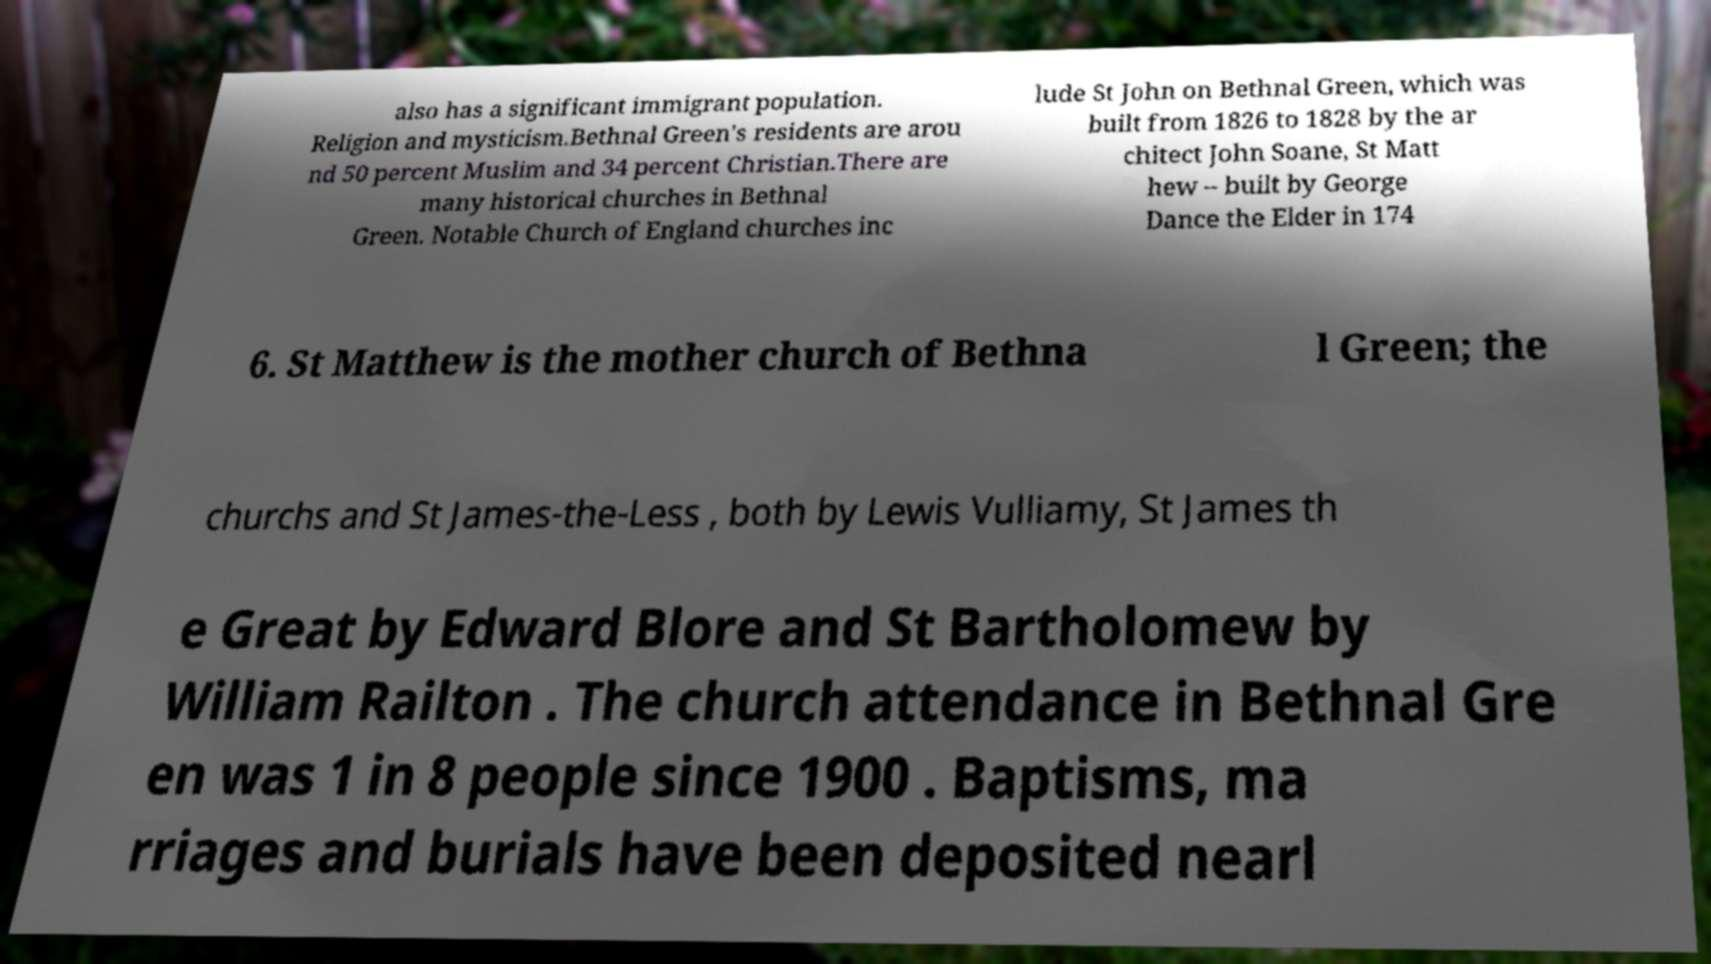Please read and relay the text visible in this image. What does it say? also has a significant immigrant population. Religion and mysticism.Bethnal Green's residents are arou nd 50 percent Muslim and 34 percent Christian.There are many historical churches in Bethnal Green. Notable Church of England churches inc lude St John on Bethnal Green, which was built from 1826 to 1828 by the ar chitect John Soane, St Matt hew – built by George Dance the Elder in 174 6. St Matthew is the mother church of Bethna l Green; the churchs and St James-the-Less , both by Lewis Vulliamy, St James th e Great by Edward Blore and St Bartholomew by William Railton . The church attendance in Bethnal Gre en was 1 in 8 people since 1900 . Baptisms, ma rriages and burials have been deposited nearl 